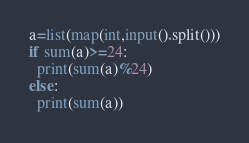<code> <loc_0><loc_0><loc_500><loc_500><_Python_>a=list(map(int,input().split()))
if sum(a)>=24:
  print(sum(a)%24)
else:
  print(sum(a))</code> 